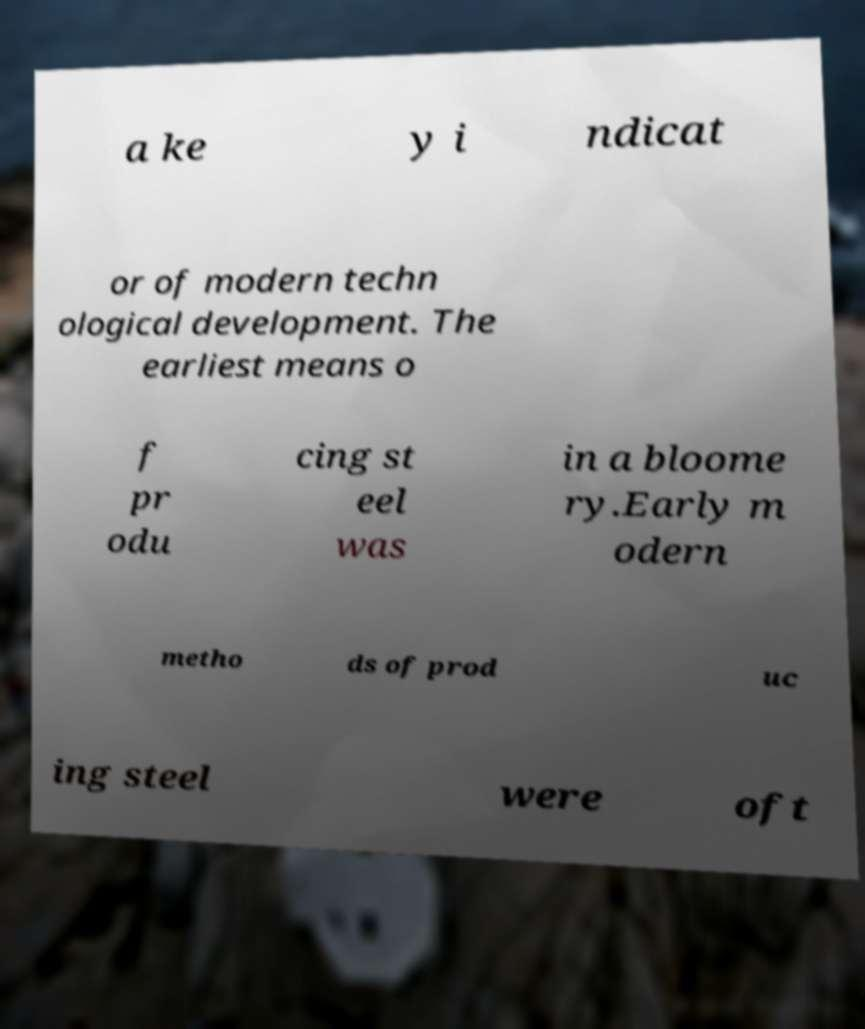I need the written content from this picture converted into text. Can you do that? a ke y i ndicat or of modern techn ological development. The earliest means o f pr odu cing st eel was in a bloome ry.Early m odern metho ds of prod uc ing steel were oft 